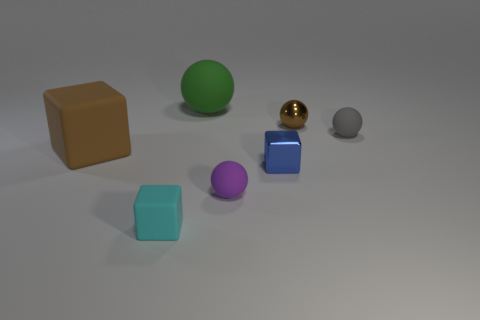Add 2 blue metallic objects. How many objects exist? 9 Subtract all cubes. How many objects are left? 4 Subtract all large brown things. Subtract all tiny cyan cubes. How many objects are left? 5 Add 4 big brown rubber objects. How many big brown rubber objects are left? 5 Add 1 blue cubes. How many blue cubes exist? 2 Subtract 1 purple spheres. How many objects are left? 6 